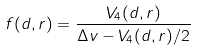Convert formula to latex. <formula><loc_0><loc_0><loc_500><loc_500>f ( d , r ) = \frac { V _ { 4 } ( d , r ) } { \Delta v - V _ { 4 } ( d , r ) / 2 }</formula> 